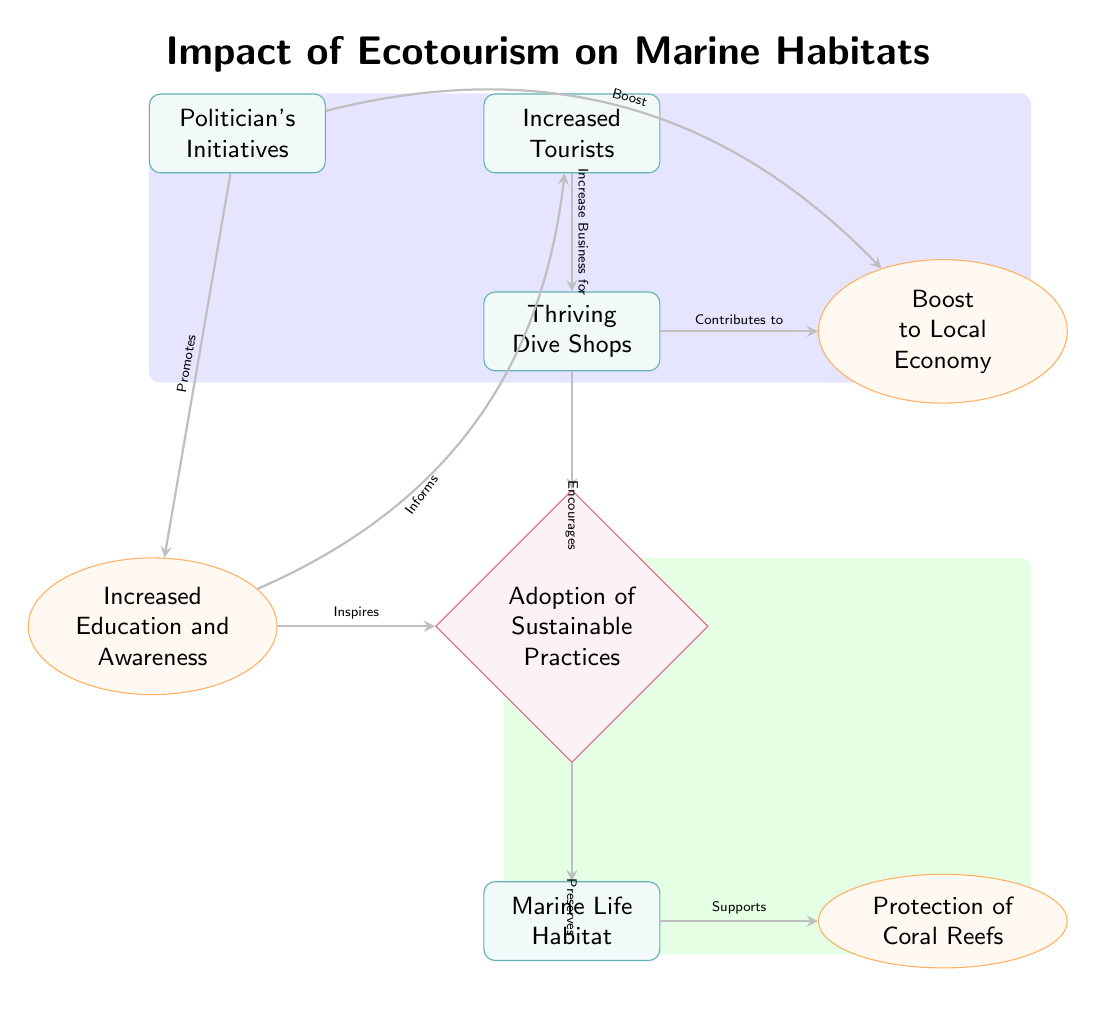What is the outcome associated with the increased education and awareness? The diagram shows that increased education and awareness leads to the inspiration for sustainable practices. Therefore, it is an outcome facilitating better environmental stewardship.
Answer: Inspires sustainable practices How many nodes are present in the diagram? By counting all the unique elements that represent entities, outcomes, and actions, I find that there are eight nodes in total: Increased Tourists, Thriving Dive Shops, Boost to Local Economy, Politician's Initiatives, Adoption of Sustainable Practices, Marine Life Habitat, Protection of Coral Reefs, and Increased Education and Awareness.
Answer: Eight What action is taken by dive shops towards the environment? The relationship depicted indicates that dive shops encourage the adoption of sustainable practices which directly impact environmental conservation efforts.
Answer: Encourages sustainable practices Which entity contributes to the boost of the local economy? Following the flow from the entities, it is clear that politicians' initiatives directly boost the local economy. This shows a connection between policy and economic growth.
Answer: Politician's Initiatives What is preserved by the adoption of sustainable practices? The diagram connects the adoption of sustainable practices to the preservation of marine life habitat, indicating that these practices are vital for maintaining ecological balance.
Answer: Marine Life Habitat Which node is directly influenced by the increased tourists? The diagram illustrates that increased tourists lead to a greater business for dive shops, creating a direct influence on local enterprises.
Answer: Thriving Dive Shops What effect do politician's initiatives have on education in the community? The flow of the diagram indicates that politician's initiatives promote increased education and awareness, which suggests that these policies seek to enhance understanding of environmental issues within the community.
Answer: Promotes education awareness What is the relationship between sustainable practices and coral reefs? The diagram indicates that sustainable practices preserve marine life habitat, which, in turn, supports coral reefs. This chain emphasizes the importance of sustainability to marine ecosystems.
Answer: Supports coral reefs 